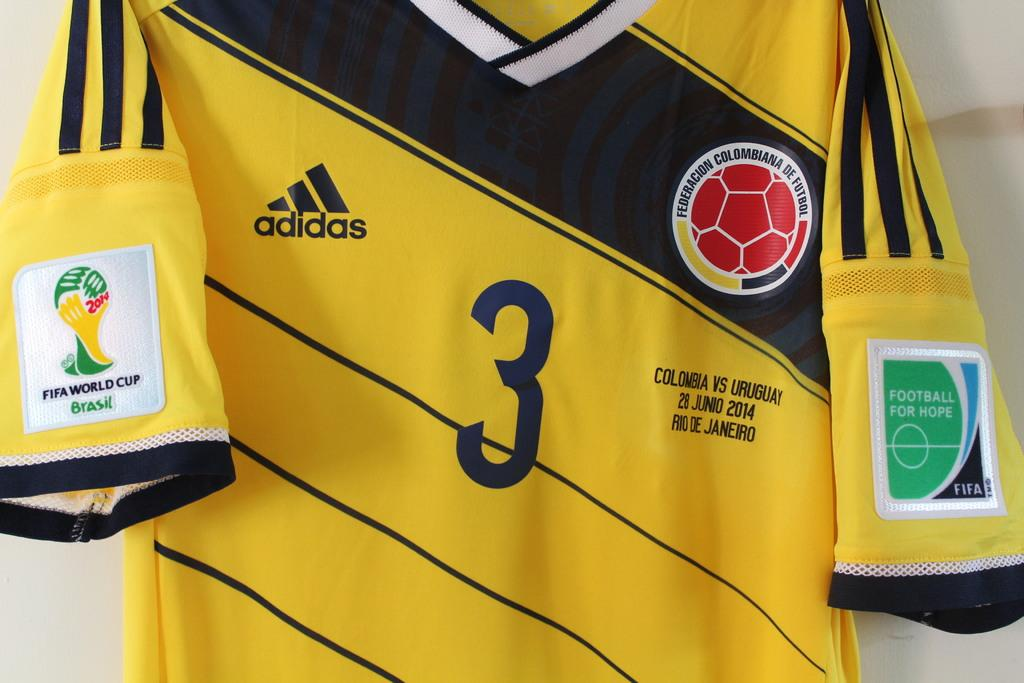<image>
Relay a brief, clear account of the picture shown. A close up of a yellow Columbian football top bearing the number 3 and the Adidas logo 